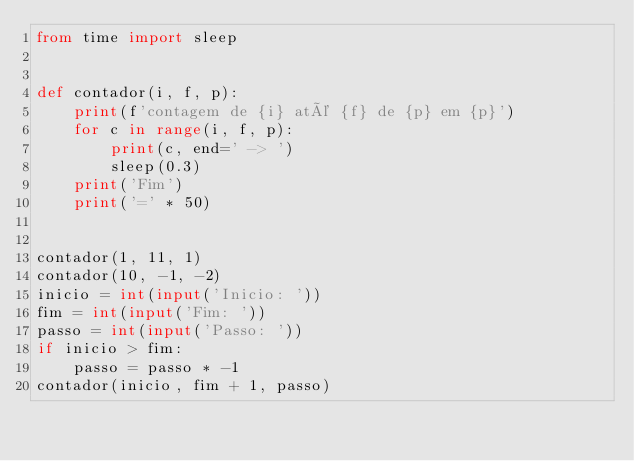<code> <loc_0><loc_0><loc_500><loc_500><_Python_>from time import sleep


def contador(i, f, p):
    print(f'contagem de {i} até {f} de {p} em {p}')
    for c in range(i, f, p):
        print(c, end=' -> ')
        sleep(0.3)
    print('Fim')
    print('=' * 50)


contador(1, 11, 1)
contador(10, -1, -2)
inicio = int(input('Inicio: '))
fim = int(input('Fim: '))
passo = int(input('Passo: '))
if inicio > fim:
    passo = passo * -1
contador(inicio, fim + 1, passo)
</code> 